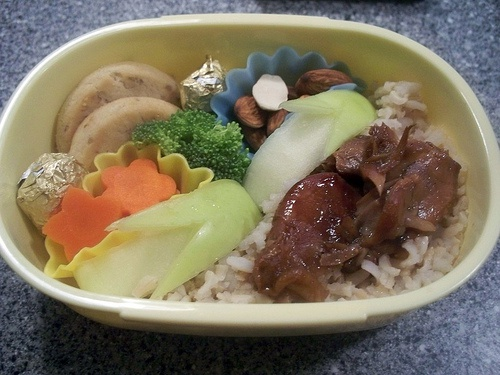Describe the objects in this image and their specific colors. I can see bowl in gray, tan, maroon, and olive tones, dining table in gray and black tones, carrot in gray, red, and salmon tones, and broccoli in gray, darkgreen, and green tones in this image. 